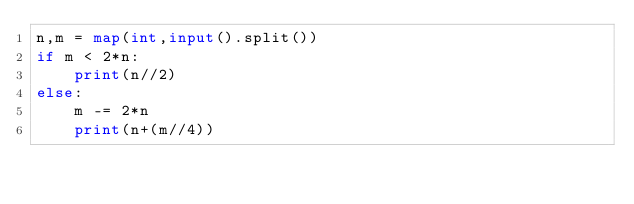<code> <loc_0><loc_0><loc_500><loc_500><_Python_>n,m = map(int,input().split())
if m < 2*n:
	print(n//2)
else:
	m -= 2*n
	print(n+(m//4))</code> 